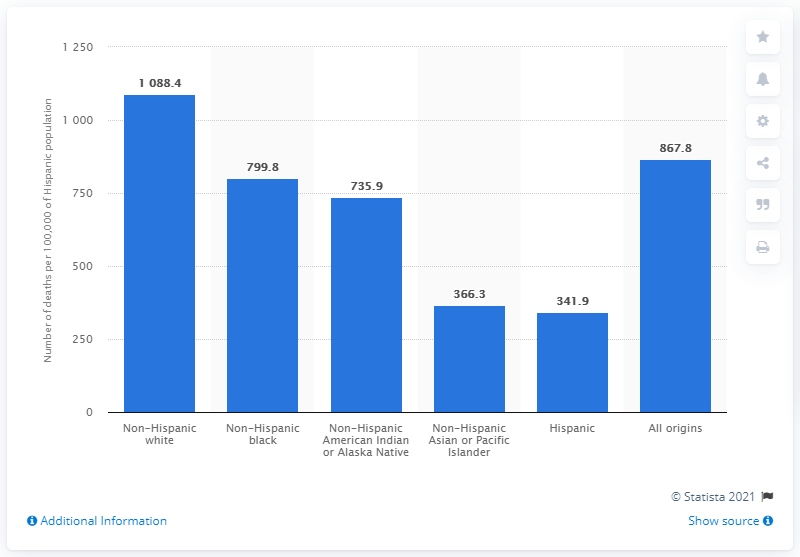Mention a couple of crucial points in this snapshot. The death rate for the Hispanic population in 2018 was 341.9 per 100,000 population. 